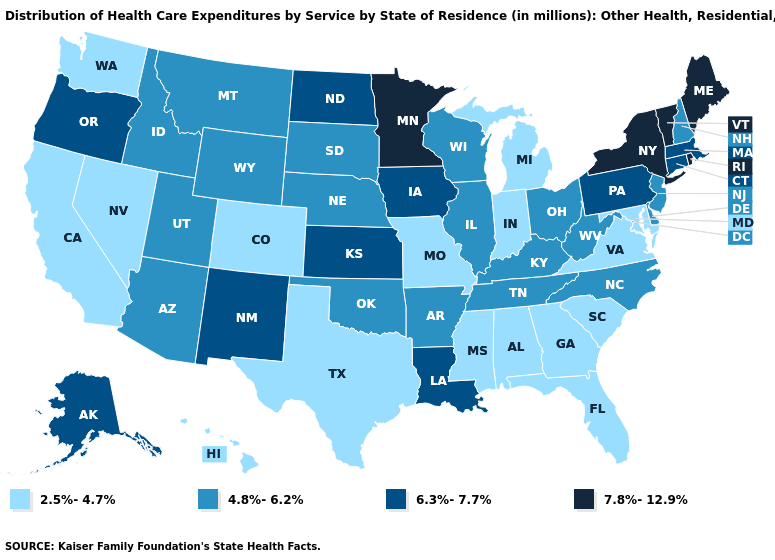Does the first symbol in the legend represent the smallest category?
Quick response, please. Yes. Does Texas have a lower value than Washington?
Concise answer only. No. Name the states that have a value in the range 4.8%-6.2%?
Be succinct. Arizona, Arkansas, Delaware, Idaho, Illinois, Kentucky, Montana, Nebraska, New Hampshire, New Jersey, North Carolina, Ohio, Oklahoma, South Dakota, Tennessee, Utah, West Virginia, Wisconsin, Wyoming. What is the highest value in the West ?
Be succinct. 6.3%-7.7%. Name the states that have a value in the range 4.8%-6.2%?
Concise answer only. Arizona, Arkansas, Delaware, Idaho, Illinois, Kentucky, Montana, Nebraska, New Hampshire, New Jersey, North Carolina, Ohio, Oklahoma, South Dakota, Tennessee, Utah, West Virginia, Wisconsin, Wyoming. What is the value of Idaho?
Short answer required. 4.8%-6.2%. What is the value of Arkansas?
Concise answer only. 4.8%-6.2%. What is the value of Utah?
Give a very brief answer. 4.8%-6.2%. Name the states that have a value in the range 6.3%-7.7%?
Short answer required. Alaska, Connecticut, Iowa, Kansas, Louisiana, Massachusetts, New Mexico, North Dakota, Oregon, Pennsylvania. Name the states that have a value in the range 7.8%-12.9%?
Quick response, please. Maine, Minnesota, New York, Rhode Island, Vermont. Among the states that border North Carolina , does Tennessee have the lowest value?
Short answer required. No. What is the lowest value in states that border Minnesota?
Concise answer only. 4.8%-6.2%. Among the states that border Idaho , which have the highest value?
Give a very brief answer. Oregon. What is the value of New York?
Keep it brief. 7.8%-12.9%. Which states have the lowest value in the West?
Answer briefly. California, Colorado, Hawaii, Nevada, Washington. 